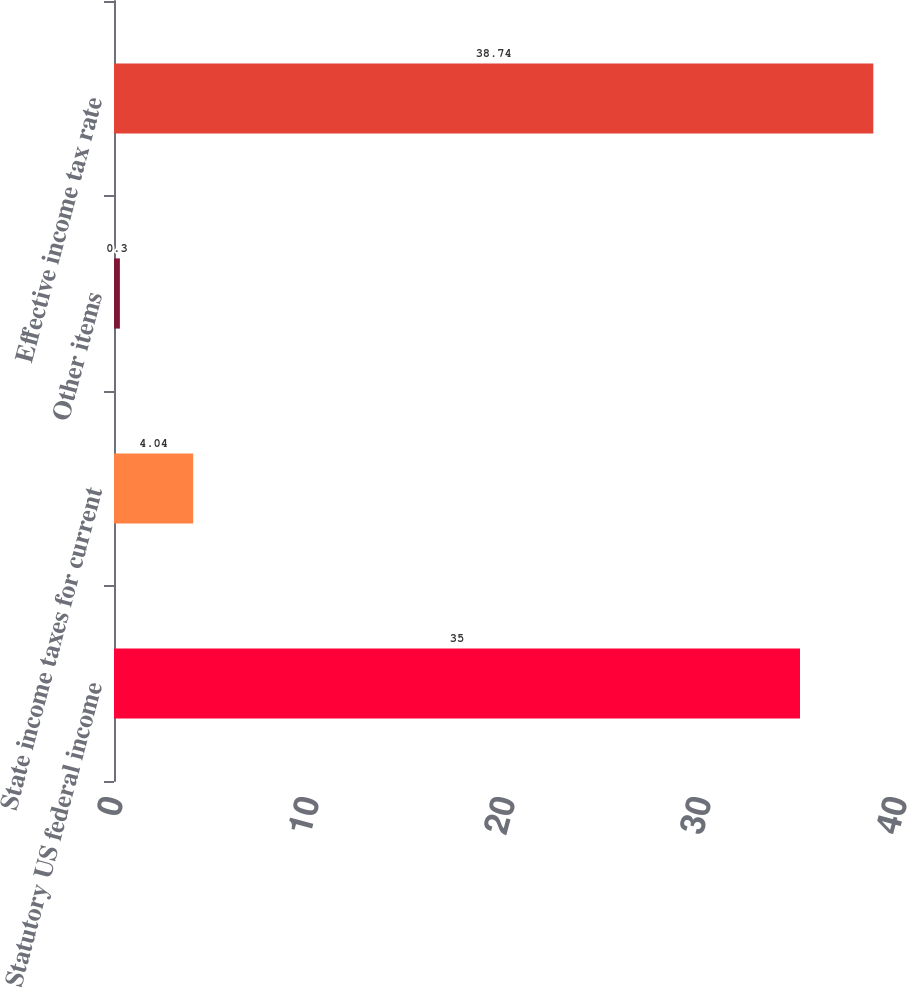Convert chart to OTSL. <chart><loc_0><loc_0><loc_500><loc_500><bar_chart><fcel>Statutory US federal income<fcel>State income taxes for current<fcel>Other items<fcel>Effective income tax rate<nl><fcel>35<fcel>4.04<fcel>0.3<fcel>38.74<nl></chart> 